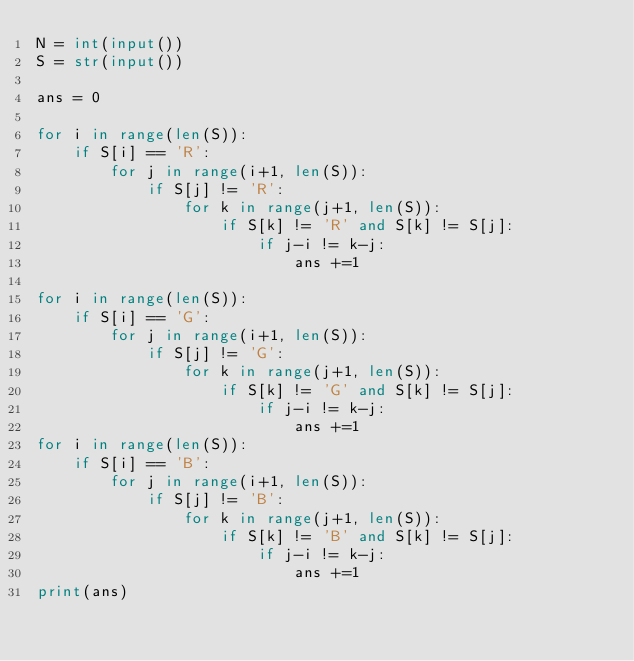<code> <loc_0><loc_0><loc_500><loc_500><_Python_>N = int(input())
S = str(input())

ans = 0

for i in range(len(S)):
    if S[i] == 'R':
        for j in range(i+1, len(S)):
            if S[j] != 'R':
                for k in range(j+1, len(S)):
                    if S[k] != 'R' and S[k] != S[j]:
                        if j-i != k-j:
                            ans +=1

for i in range(len(S)):
    if S[i] == 'G':
        for j in range(i+1, len(S)):
            if S[j] != 'G':
                for k in range(j+1, len(S)):
                    if S[k] != 'G' and S[k] != S[j]:
                        if j-i != k-j:
                            ans +=1
for i in range(len(S)):
    if S[i] == 'B':
        for j in range(i+1, len(S)):
            if S[j] != 'B':
                for k in range(j+1, len(S)):
                    if S[k] != 'B' and S[k] != S[j]:
                        if j-i != k-j:
                            ans +=1
print(ans)</code> 